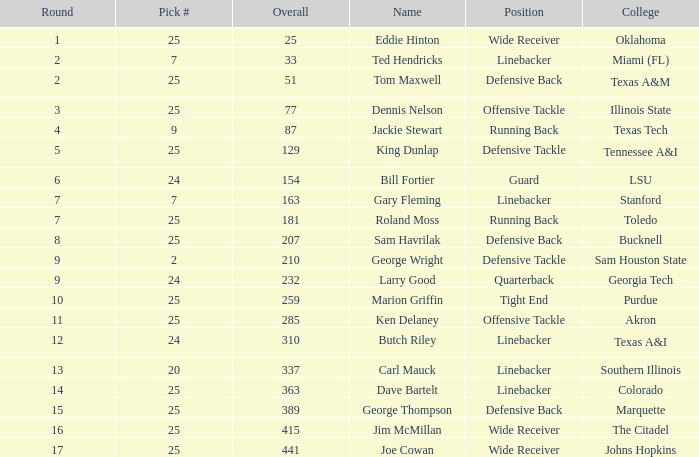Can you parse all the data within this table? {'header': ['Round', 'Pick #', 'Overall', 'Name', 'Position', 'College'], 'rows': [['1', '25', '25', 'Eddie Hinton', 'Wide Receiver', 'Oklahoma'], ['2', '7', '33', 'Ted Hendricks', 'Linebacker', 'Miami (FL)'], ['2', '25', '51', 'Tom Maxwell', 'Defensive Back', 'Texas A&M'], ['3', '25', '77', 'Dennis Nelson', 'Offensive Tackle', 'Illinois State'], ['4', '9', '87', 'Jackie Stewart', 'Running Back', 'Texas Tech'], ['5', '25', '129', 'King Dunlap', 'Defensive Tackle', 'Tennessee A&I'], ['6', '24', '154', 'Bill Fortier', 'Guard', 'LSU'], ['7', '7', '163', 'Gary Fleming', 'Linebacker', 'Stanford'], ['7', '25', '181', 'Roland Moss', 'Running Back', 'Toledo'], ['8', '25', '207', 'Sam Havrilak', 'Defensive Back', 'Bucknell'], ['9', '2', '210', 'George Wright', 'Defensive Tackle', 'Sam Houston State'], ['9', '24', '232', 'Larry Good', 'Quarterback', 'Georgia Tech'], ['10', '25', '259', 'Marion Griffin', 'Tight End', 'Purdue'], ['11', '25', '285', 'Ken Delaney', 'Offensive Tackle', 'Akron'], ['12', '24', '310', 'Butch Riley', 'Linebacker', 'Texas A&I'], ['13', '20', '337', 'Carl Mauck', 'Linebacker', 'Southern Illinois'], ['14', '25', '363', 'Dave Bartelt', 'Linebacker', 'Colorado'], ['15', '25', '389', 'George Thompson', 'Defensive Back', 'Marquette'], ['16', '25', '415', 'Jim McMillan', 'Wide Receiver', 'The Citadel'], ['17', '25', '441', 'Joe Cowan', 'Wide Receiver', 'Johns Hopkins']]} Choose # of 25, and a sum of 207 is known as what? Sam Havrilak. 